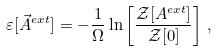<formula> <loc_0><loc_0><loc_500><loc_500>\varepsilon [ \vec { A } ^ { e x t } ] = - \frac { 1 } { \Omega } \ln \left [ \frac { { \mathcal { Z } } [ A ^ { e x t } ] } { { \mathcal { Z } } [ 0 ] } \right ] \, ,</formula> 